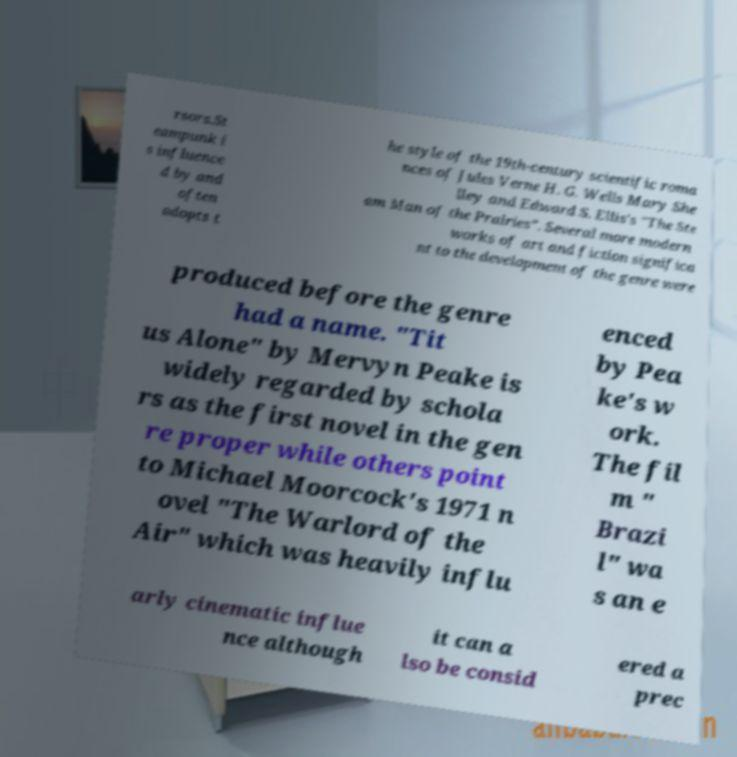Can you read and provide the text displayed in the image?This photo seems to have some interesting text. Can you extract and type it out for me? rsors.St eampunk i s influence d by and often adopts t he style of the 19th-century scientific roma nces of Jules Verne H. G. Wells Mary She lley and Edward S. Ellis's "The Ste am Man of the Prairies". Several more modern works of art and fiction significa nt to the development of the genre were produced before the genre had a name. "Tit us Alone" by Mervyn Peake is widely regarded by schola rs as the first novel in the gen re proper while others point to Michael Moorcock's 1971 n ovel "The Warlord of the Air" which was heavily influ enced by Pea ke's w ork. The fil m " Brazi l" wa s an e arly cinematic influe nce although it can a lso be consid ered a prec 